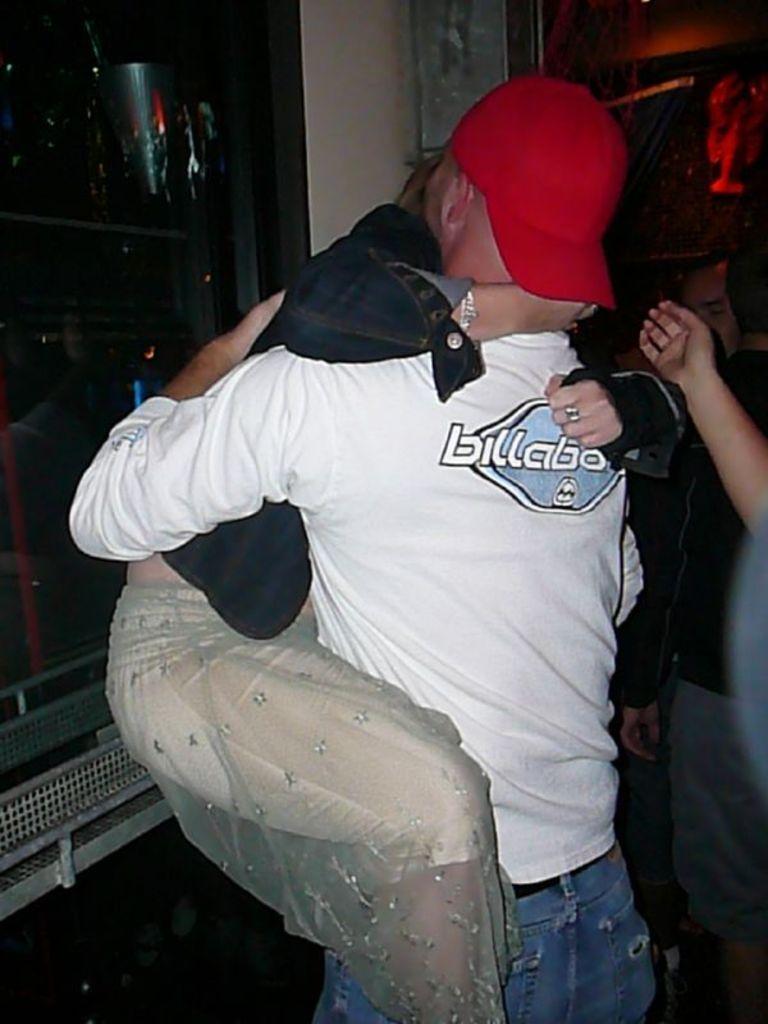How would you summarize this image in a sentence or two? A couple is hugging each other wearing clothes. 